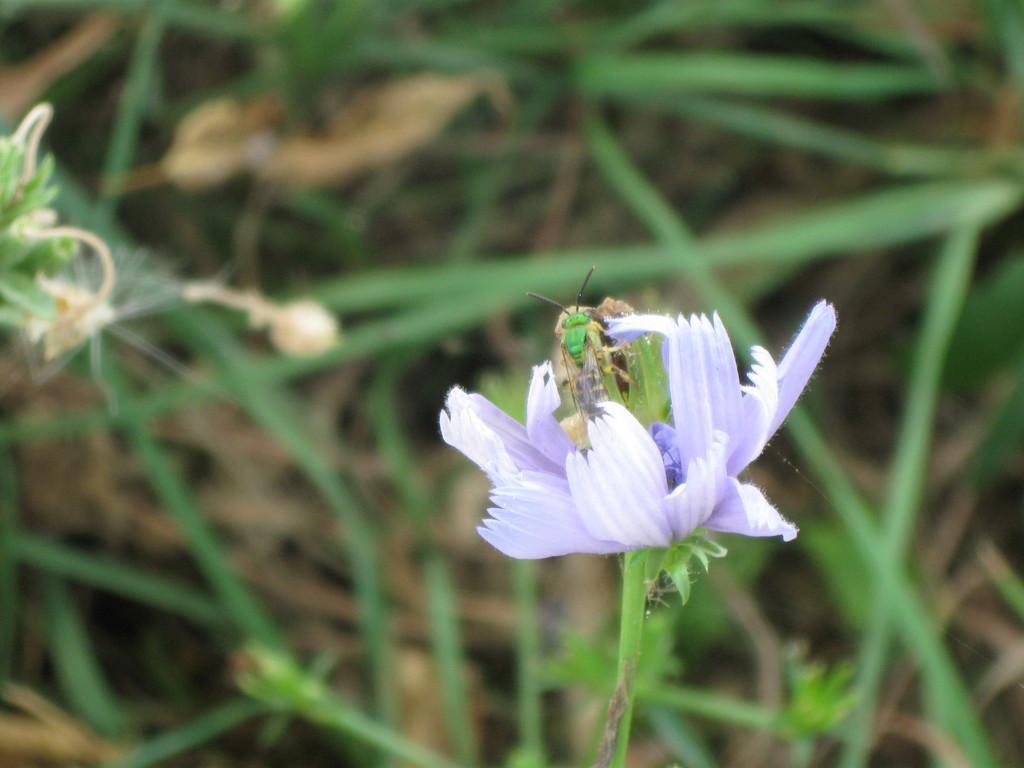How would you summarize this image in a sentence or two? There is an insect on a flower in the foreground area of the image. 